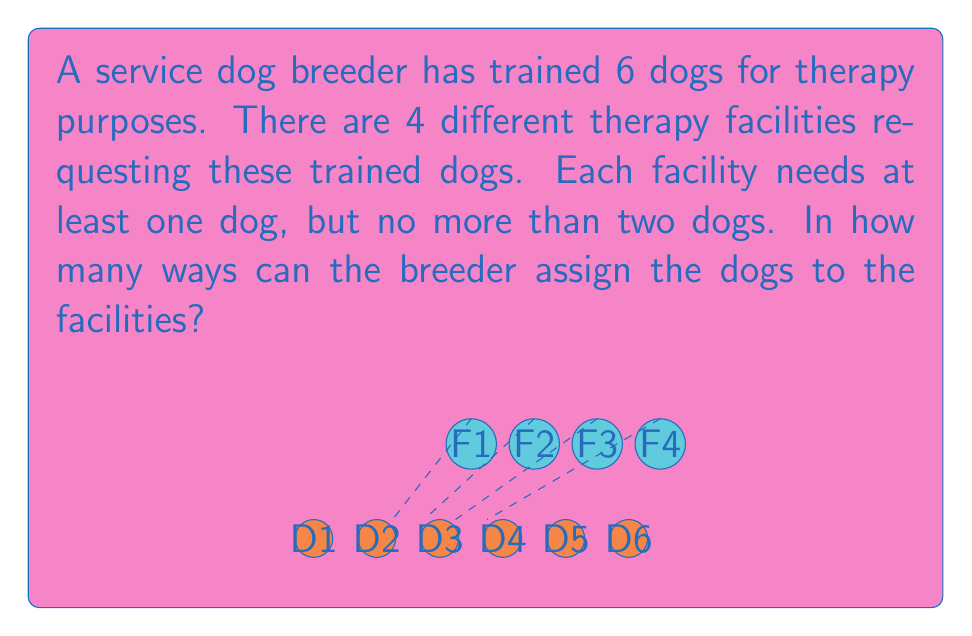Show me your answer to this math problem. Let's approach this step-by-step:

1) First, we need to consider the possible distributions of dogs that satisfy the conditions:
   - Each facility gets at least one dog
   - No facility gets more than two dogs
   - All 6 dogs are distributed

2) The only valid distribution is: two facilities get 2 dogs each, and two facilities get 1 dog each.

3) Now, we can break this down into steps:
   a) Choose 2 facilities out of 4 to receive 2 dogs each: $\binom{4}{2}$ ways
   b) For each of these choices, we need to select 4 dogs out of 6 to go to these two facilities: $\binom{6}{4}$ ways
   c) Then, we need to distribute these 4 dogs between the two chosen facilities: $\binom{4}{2}$ ways
   d) Finally, we need to distribute the remaining 2 dogs to the other two facilities: 2! ways

4) By the multiplication principle, we multiply these together:

   $$\binom{4}{2} \cdot \binom{6}{4} \cdot \binom{4}{2} \cdot 2!$$

5) Let's calculate each part:
   $\binom{4}{2} = 6$
   $\binom{6}{4} = 15$
   $\binom{4}{2} = 6$
   $2! = 2$

6) Multiplying these together:
   $$6 \cdot 15 \cdot 6 \cdot 2 = 1080$$

Therefore, there are 1080 ways to assign the dogs to the facilities.
Answer: 1080 